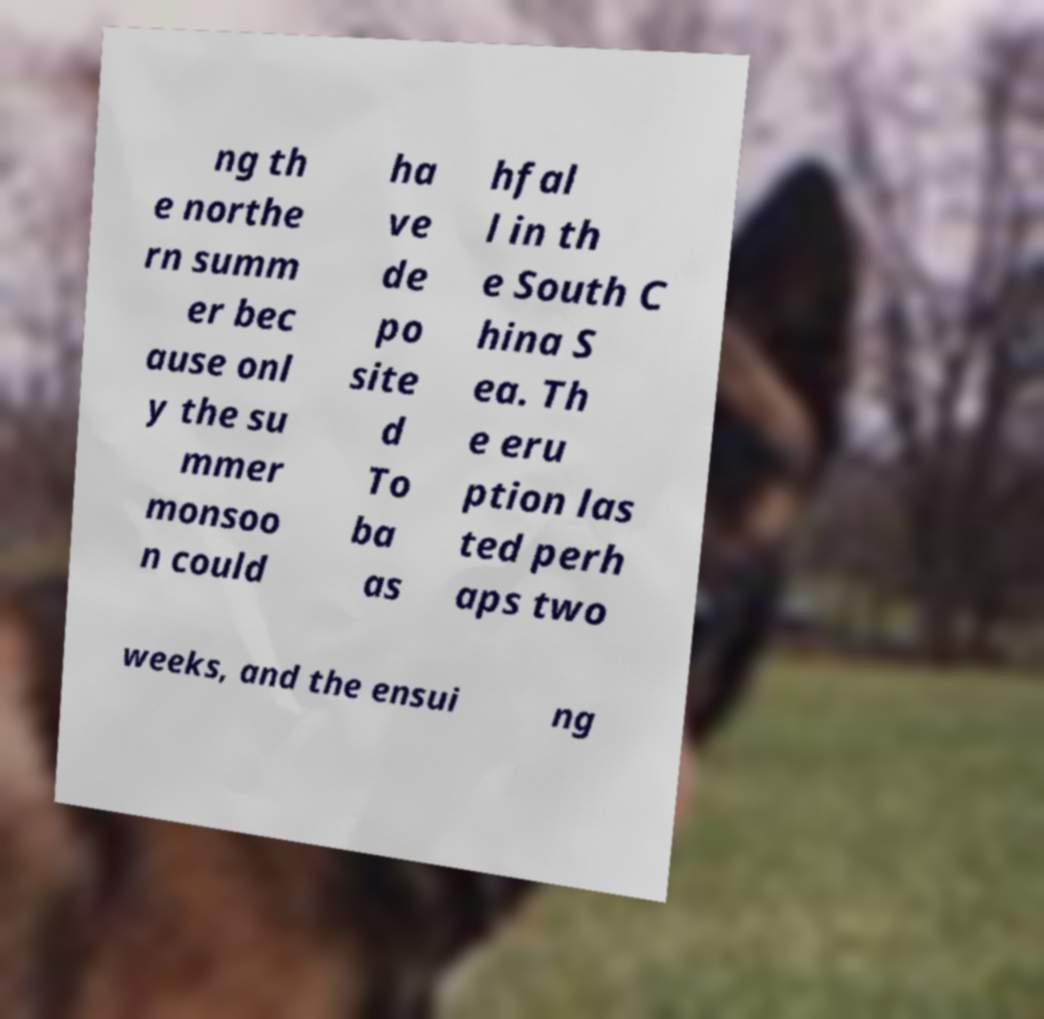Can you accurately transcribe the text from the provided image for me? ng th e northe rn summ er bec ause onl y the su mmer monsoo n could ha ve de po site d To ba as hfal l in th e South C hina S ea. Th e eru ption las ted perh aps two weeks, and the ensui ng 